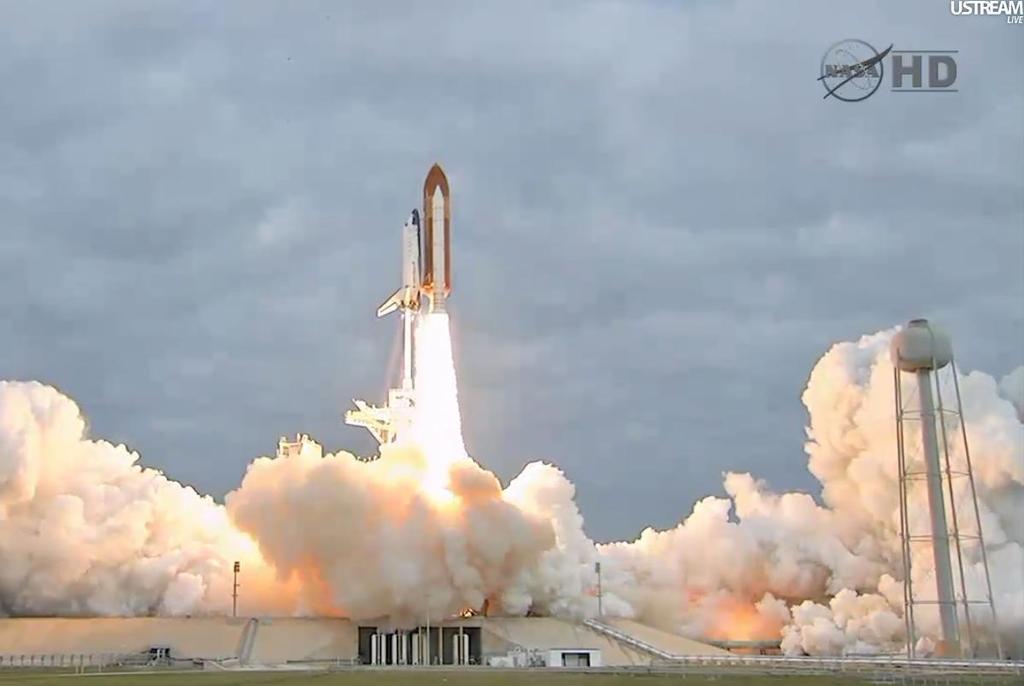Could you give a brief overview of what you see in this image? In the center of the image there is a rocket in the air. At the bottom of the image we can see fire, smoke, tower and building. In the background there are clouds and sky. 